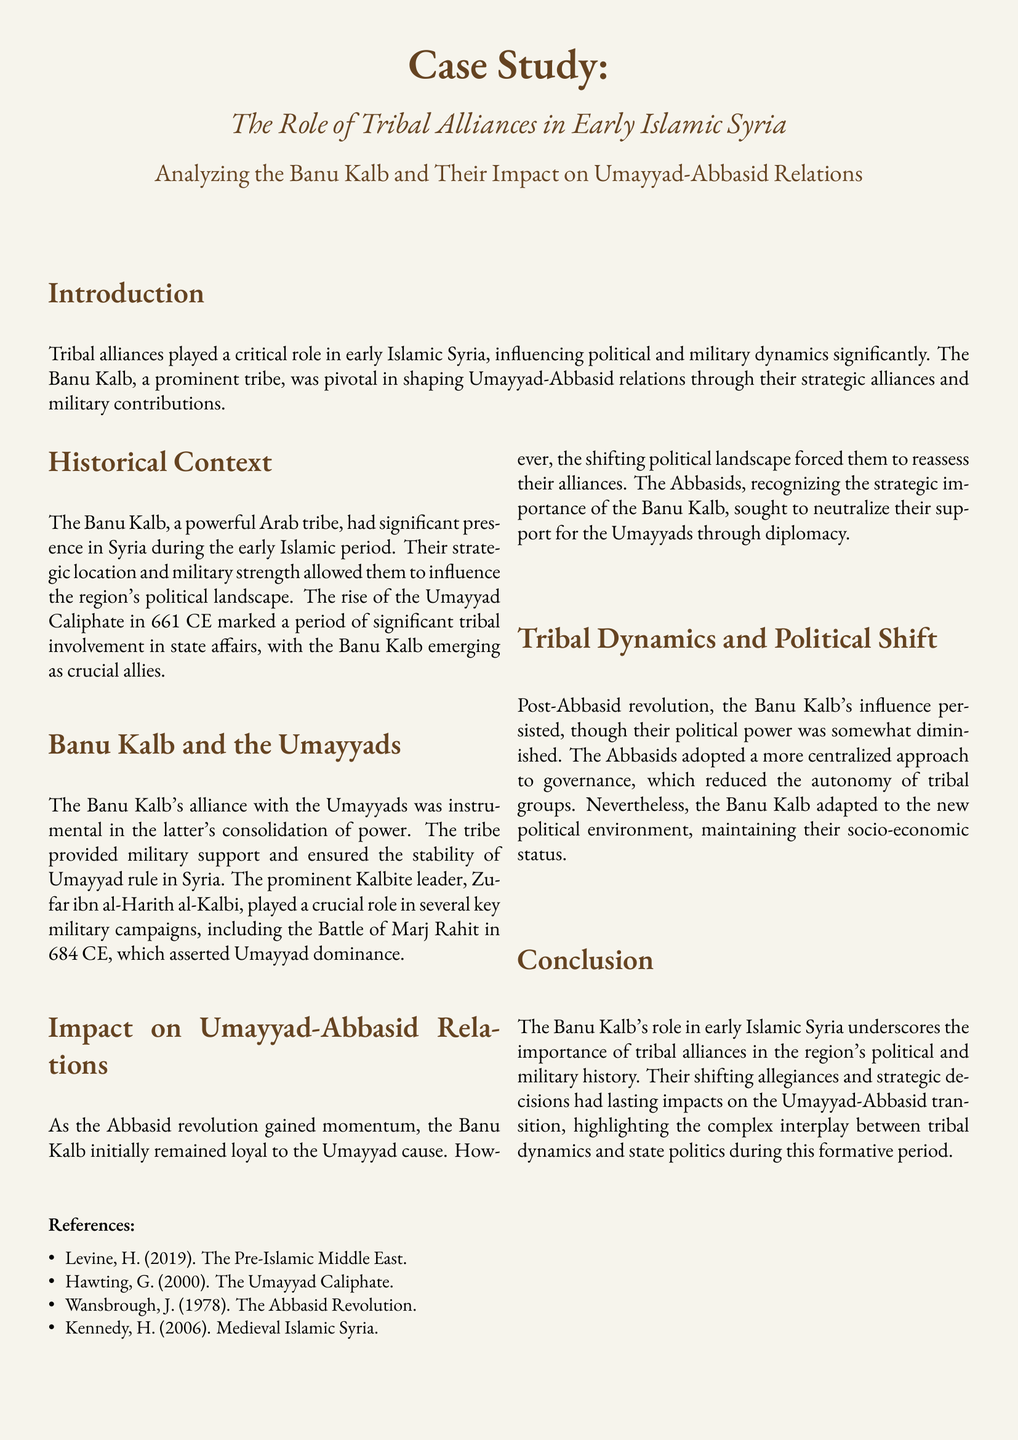What was the pivotal tribe in early Islamic Syria? The document states that the Banu Kalb was a prominent tribe that played a critical role in shaping the political landscape.
Answer: Banu Kalb Who was the prominent Kalbite leader mentioned? The text identifies Zufar ibn al-Harith al-Kalbi as a significant leader who contributed to military campaigns.
Answer: Zufar ibn al-Harith al-Kalbi In which year did the Battle of Marj Rahit occur? The document specifies that the Battle of Marj Rahit took place in 684 CE, which asserted Umayyad dominance.
Answer: 684 CE What approach did the Abbasids adopt post-revolution? The document discusses the Abbasids' shift towards a centralized approach to governance after the revolution.
Answer: Centralized approach What was the Banu Kalb's initial stance during the Abbasid revolution? The text indicates that the Banu Kalb initially remained loyal to the Umayyad cause before reassessing their alliances.
Answer: Loyal to the Umayyads What impact did the Banu Kalb have on Umayyad-Abbasid relations? The document explains that the Banu Kalb's strategic decision-making significantly influenced the relations between the two caliphates.
Answer: Significant influence How did the Banu Kalb maintain their status post-Abbasid revolution? The text mentions that the Banu Kalb adapted to the new political environment, sustaining their socio-economic status.
Answer: Maintained socio-economic status What area did the Banu Kalb influence through military support? The document states that the Banu Kalb's military strength had implications for the stability of Umayyad rule in Syria.
Answer: Umayyad rule in Syria 